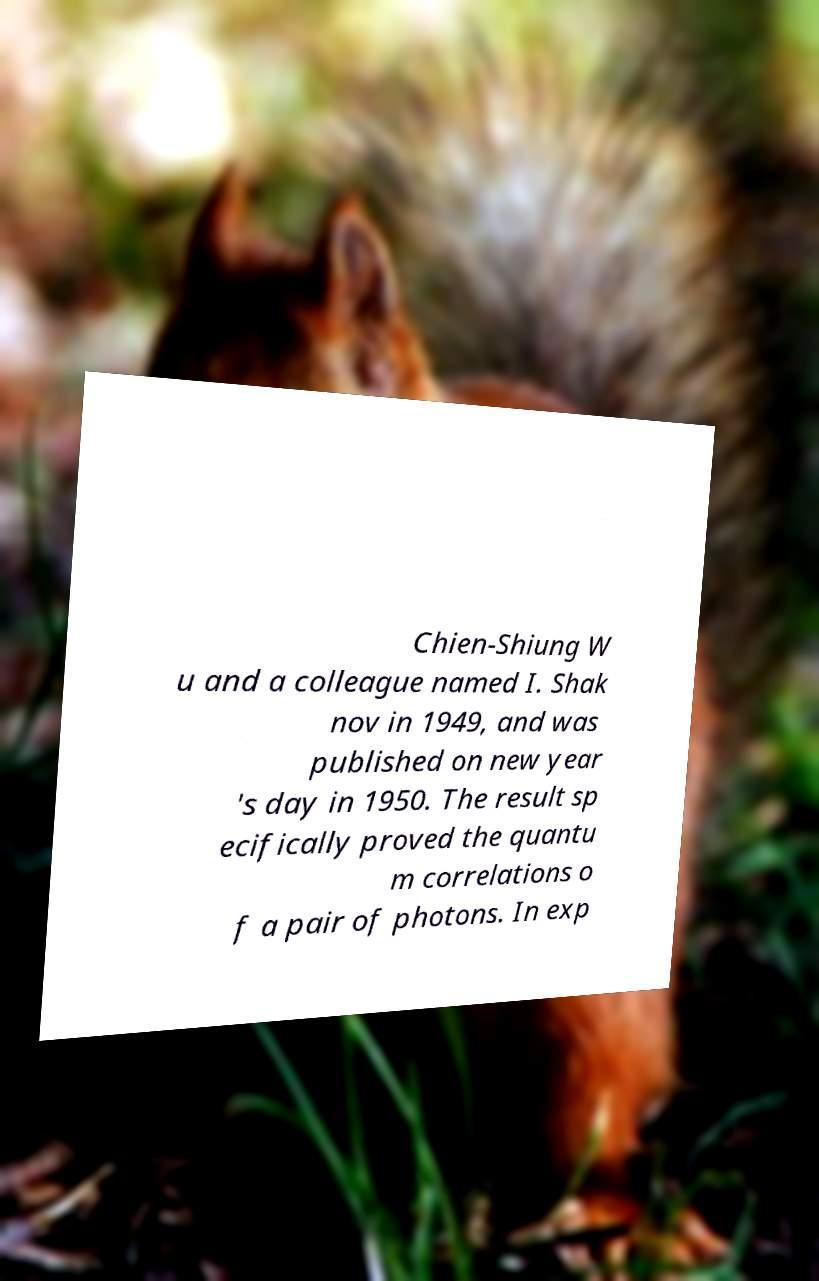I need the written content from this picture converted into text. Can you do that? Chien-Shiung W u and a colleague named I. Shak nov in 1949, and was published on new year 's day in 1950. The result sp ecifically proved the quantu m correlations o f a pair of photons. In exp 